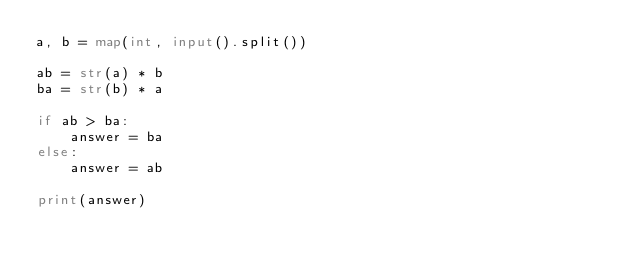<code> <loc_0><loc_0><loc_500><loc_500><_Python_>a, b = map(int, input().split())

ab = str(a) * b
ba = str(b) * a

if ab > ba:
    answer = ba
else:
    answer = ab
    
print(answer)</code> 